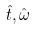Convert formula to latex. <formula><loc_0><loc_0><loc_500><loc_500>\hat { t } , \hat { \omega }</formula> 